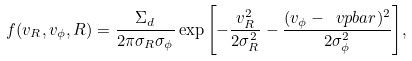Convert formula to latex. <formula><loc_0><loc_0><loc_500><loc_500>f ( v _ { R } , v _ { \phi } , R ) = \frac { \Sigma _ { d } } { 2 \pi \sigma _ { R } \sigma _ { \phi } } \exp { \left [ - \frac { v _ { R } ^ { 2 } } { 2 \sigma _ { R } ^ { 2 } } - \frac { ( v _ { \phi } - \ v p b a r ) ^ { 2 } } { 2 \sigma _ { \phi } ^ { 2 } } \right ] } ,</formula> 